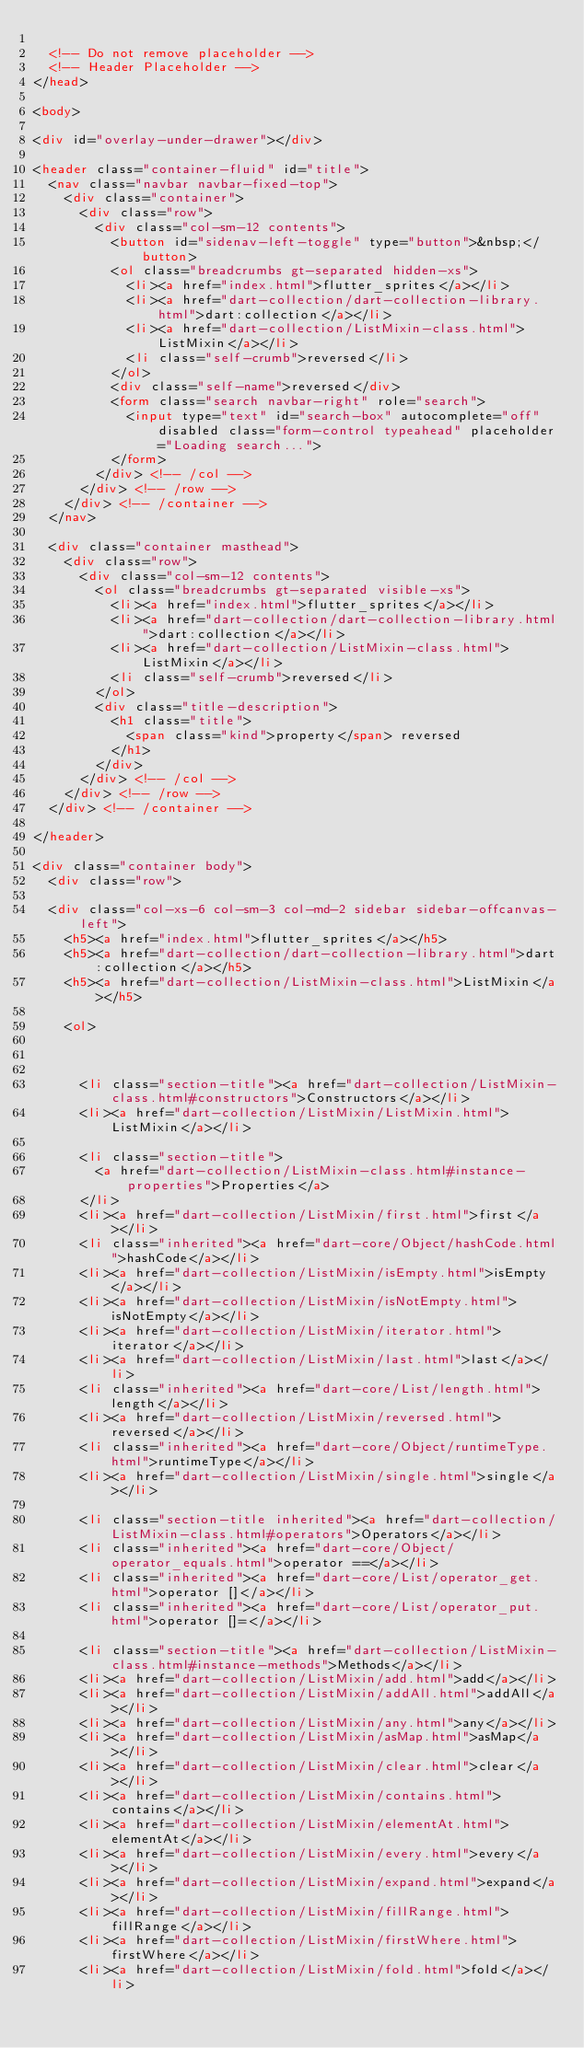Convert code to text. <code><loc_0><loc_0><loc_500><loc_500><_HTML_>
  <!-- Do not remove placeholder -->
  <!-- Header Placeholder -->
</head>

<body>

<div id="overlay-under-drawer"></div>

<header class="container-fluid" id="title">
  <nav class="navbar navbar-fixed-top">
    <div class="container">
      <div class="row">
        <div class="col-sm-12 contents">
          <button id="sidenav-left-toggle" type="button">&nbsp;</button>
          <ol class="breadcrumbs gt-separated hidden-xs">
            <li><a href="index.html">flutter_sprites</a></li>
            <li><a href="dart-collection/dart-collection-library.html">dart:collection</a></li>
            <li><a href="dart-collection/ListMixin-class.html">ListMixin</a></li>
            <li class="self-crumb">reversed</li>
          </ol>
          <div class="self-name">reversed</div>
          <form class="search navbar-right" role="search">
            <input type="text" id="search-box" autocomplete="off" disabled class="form-control typeahead" placeholder="Loading search...">
          </form>
        </div> <!-- /col -->
      </div> <!-- /row -->
    </div> <!-- /container -->
  </nav>

  <div class="container masthead">
    <div class="row">
      <div class="col-sm-12 contents">
        <ol class="breadcrumbs gt-separated visible-xs">
          <li><a href="index.html">flutter_sprites</a></li>
          <li><a href="dart-collection/dart-collection-library.html">dart:collection</a></li>
          <li><a href="dart-collection/ListMixin-class.html">ListMixin</a></li>
          <li class="self-crumb">reversed</li>
        </ol>
        <div class="title-description">
          <h1 class="title">
            <span class="kind">property</span> reversed
          </h1>
        </div>
      </div> <!-- /col -->
    </div> <!-- /row -->
  </div> <!-- /container -->

</header>

<div class="container body">
  <div class="row">

  <div class="col-xs-6 col-sm-3 col-md-2 sidebar sidebar-offcanvas-left">
    <h5><a href="index.html">flutter_sprites</a></h5>
    <h5><a href="dart-collection/dart-collection-library.html">dart:collection</a></h5>
    <h5><a href="dart-collection/ListMixin-class.html">ListMixin</a></h5>

    <ol>
    
    
    
      <li class="section-title"><a href="dart-collection/ListMixin-class.html#constructors">Constructors</a></li>
      <li><a href="dart-collection/ListMixin/ListMixin.html">ListMixin</a></li>
    
      <li class="section-title">
        <a href="dart-collection/ListMixin-class.html#instance-properties">Properties</a>
      </li>
      <li><a href="dart-collection/ListMixin/first.html">first</a></li>
      <li class="inherited"><a href="dart-core/Object/hashCode.html">hashCode</a></li>
      <li><a href="dart-collection/ListMixin/isEmpty.html">isEmpty</a></li>
      <li><a href="dart-collection/ListMixin/isNotEmpty.html">isNotEmpty</a></li>
      <li><a href="dart-collection/ListMixin/iterator.html">iterator</a></li>
      <li><a href="dart-collection/ListMixin/last.html">last</a></li>
      <li class="inherited"><a href="dart-core/List/length.html">length</a></li>
      <li><a href="dart-collection/ListMixin/reversed.html">reversed</a></li>
      <li class="inherited"><a href="dart-core/Object/runtimeType.html">runtimeType</a></li>
      <li><a href="dart-collection/ListMixin/single.html">single</a></li>
    
      <li class="section-title inherited"><a href="dart-collection/ListMixin-class.html#operators">Operators</a></li>
      <li class="inherited"><a href="dart-core/Object/operator_equals.html">operator ==</a></li>
      <li class="inherited"><a href="dart-core/List/operator_get.html">operator []</a></li>
      <li class="inherited"><a href="dart-core/List/operator_put.html">operator []=</a></li>
    
      <li class="section-title"><a href="dart-collection/ListMixin-class.html#instance-methods">Methods</a></li>
      <li><a href="dart-collection/ListMixin/add.html">add</a></li>
      <li><a href="dart-collection/ListMixin/addAll.html">addAll</a></li>
      <li><a href="dart-collection/ListMixin/any.html">any</a></li>
      <li><a href="dart-collection/ListMixin/asMap.html">asMap</a></li>
      <li><a href="dart-collection/ListMixin/clear.html">clear</a></li>
      <li><a href="dart-collection/ListMixin/contains.html">contains</a></li>
      <li><a href="dart-collection/ListMixin/elementAt.html">elementAt</a></li>
      <li><a href="dart-collection/ListMixin/every.html">every</a></li>
      <li><a href="dart-collection/ListMixin/expand.html">expand</a></li>
      <li><a href="dart-collection/ListMixin/fillRange.html">fillRange</a></li>
      <li><a href="dart-collection/ListMixin/firstWhere.html">firstWhere</a></li>
      <li><a href="dart-collection/ListMixin/fold.html">fold</a></li></code> 